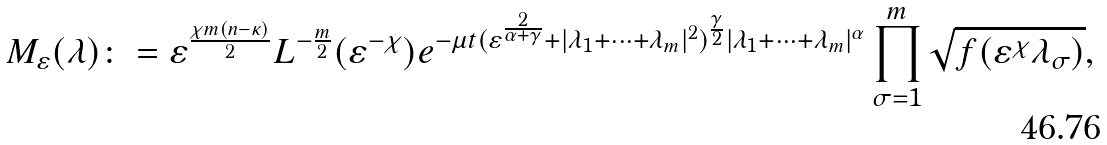<formula> <loc_0><loc_0><loc_500><loc_500>M _ { \varepsilon } ( \lambda ) \colon = \varepsilon ^ { \frac { \chi m ( n - \kappa ) } { 2 } } L ^ { - \frac { m } { 2 } } ( \varepsilon ^ { - \chi } ) e ^ { - \mu t ( \varepsilon ^ { \frac { 2 } { \alpha + \gamma } } + | \lambda _ { 1 } + \cdots + \lambda _ { m } | ^ { 2 } ) ^ { \frac { \gamma } { 2 } } | \lambda _ { 1 } + \cdots + \lambda _ { m } | ^ { \alpha } } \prod _ { \sigma = 1 } ^ { m } { \sqrt { f ( \varepsilon ^ { \chi } \lambda _ { \sigma } ) } } ,</formula> 